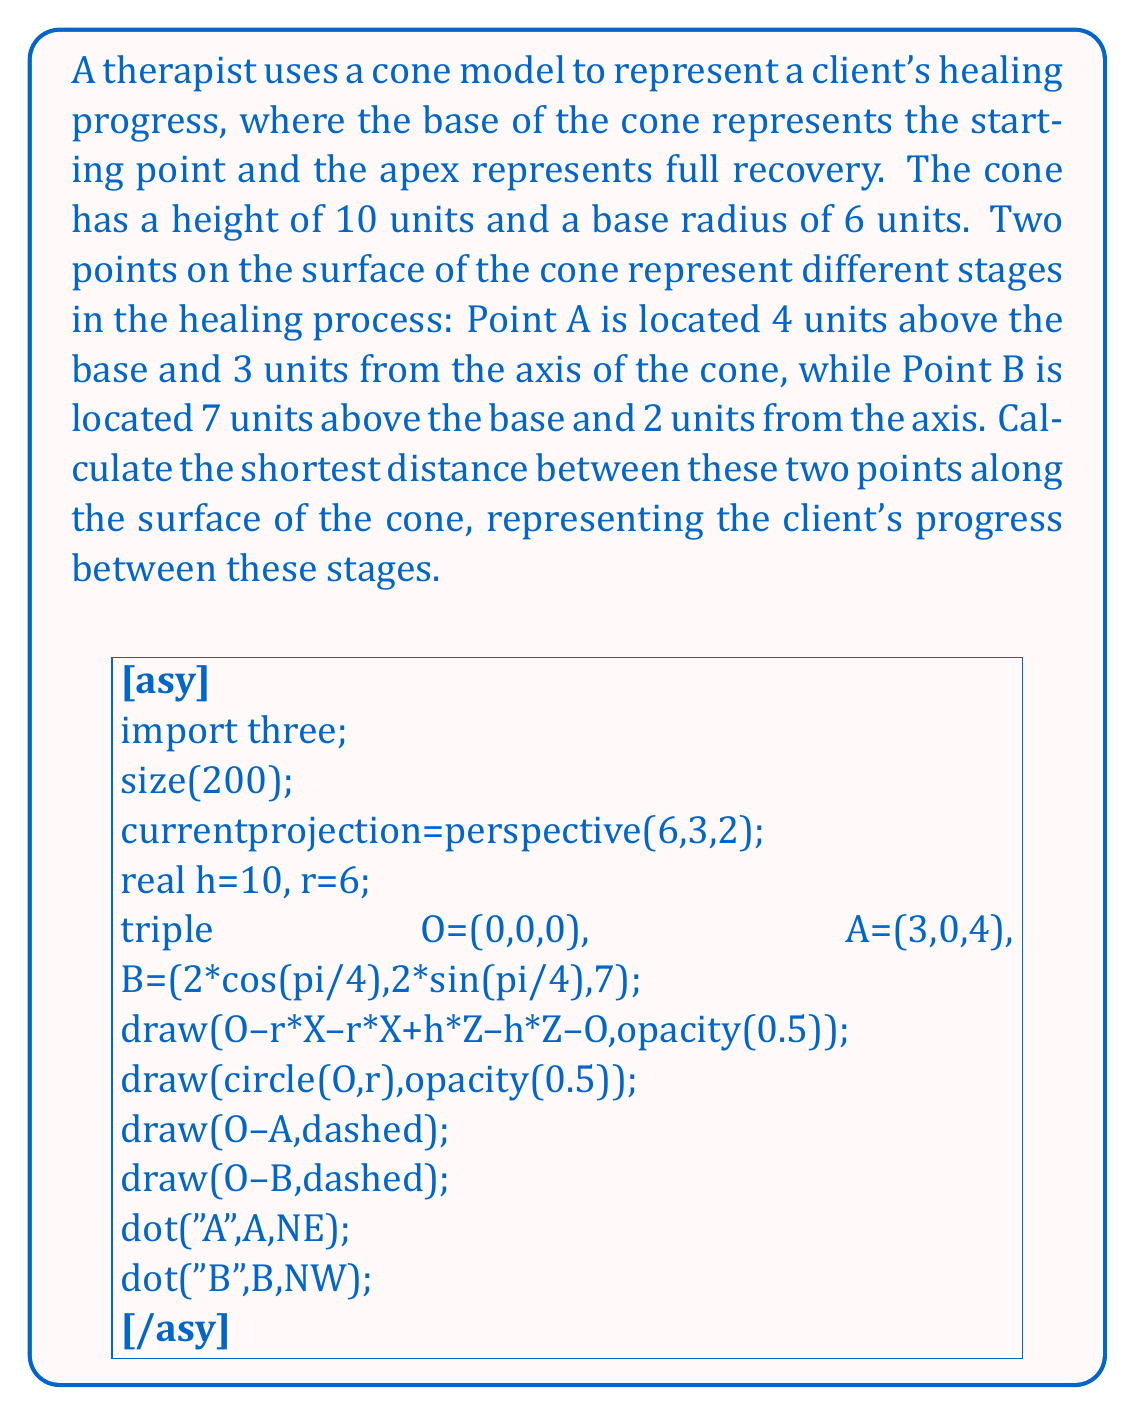Can you solve this math problem? To solve this problem, we'll follow these steps:

1) First, we need to understand that the shortest path between two points on a conical surface is not a straight line, but a geodesic curve. However, if we "unroll" the cone into a flat sector, this curve becomes a straight line.

2) To unroll the cone, we need to find its slant height and the angle of the sector:

   Slant height: $s = \sqrt{r^2 + h^2} = \sqrt{6^2 + 10^2} = \sqrt{136} \approx 11.66$ units

   Sector angle: $\theta = \frac{2\pi r}{s} = \frac{2\pi \cdot 6}{11.66} \approx 3.23$ radians

3) Now, we need to find the coordinates of points A and B on this unrolled sector. We'll use polar coordinates $(r, \phi)$ where $r$ is the distance from the apex and $\phi$ is the angle from a fixed line:

   For A: $r_A = \frac{s(10-4)}{10} = 7$ units, $\phi_A = \arccos(\frac{3}{3.6}) = 0.445$ radians
   
   For B: $r_B = \frac{s(10-7)}{10} = 3.5$ units, $\phi_B = \arccos(\frac{2}{1.8}) + \frac{\pi}{4} = 1.919$ radians

4) The distance between these points on the flat sector can be calculated using the law of cosines:

   $$d^2 = r_A^2 + r_B^2 - 2r_Ar_B\cos(\phi_B - \phi_A)$$

5) Substituting the values:

   $$d^2 = 7^2 + 3.5^2 - 2 \cdot 7 \cdot 3.5 \cdot \cos(1.919 - 0.445)$$
   $$d^2 = 49 + 12.25 - 49 \cdot \cos(1.474)$$
   $$d^2 = 61.25 - 49 \cdot 0.0919 = 56.75$$

6) Taking the square root:

   $$d = \sqrt{56.75} \approx 7.53$$

Therefore, the shortest distance between the two points on the surface of the cone is approximately 7.53 units.
Answer: The shortest distance between the two points on the surface of the cone is approximately 7.53 units. 